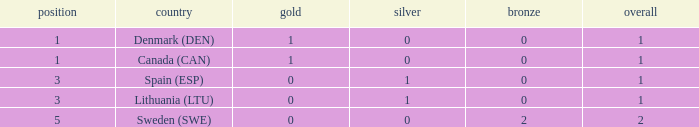What is the number of gold medals for Lithuania (ltu), when the total is more than 1? None. 